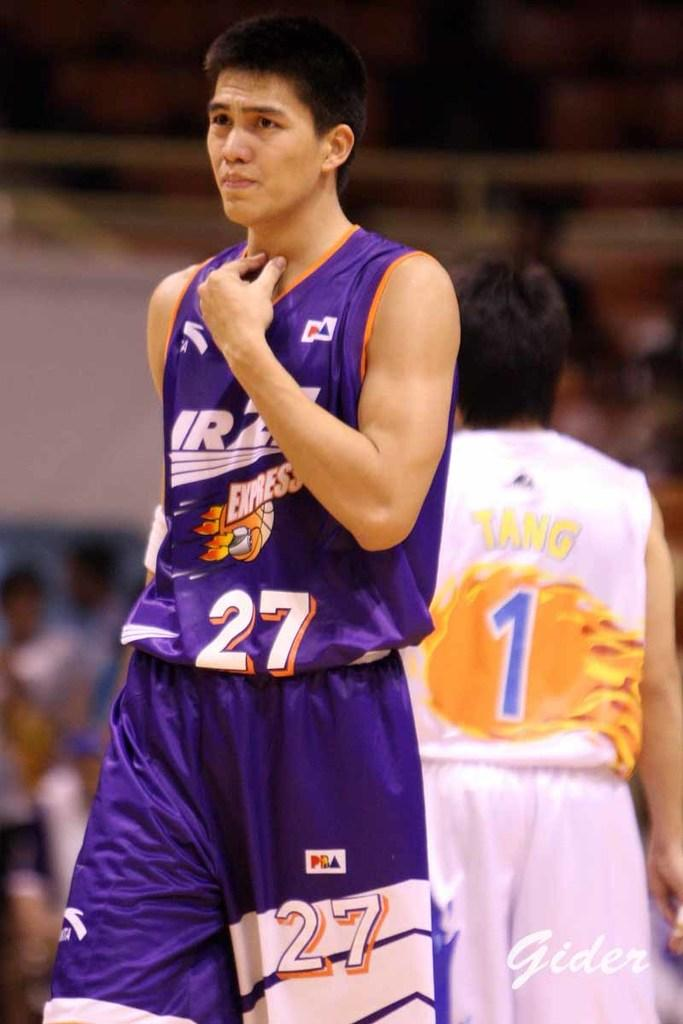What is the main action being performed by the person in the image? There is a person walking in the image. What color is the top worn by the person walking? The person is wearing a blue top. Can you describe the position of the other person in the image? There is a person standing on the right side of the image. How would you describe the background of the image? The background of the image is blurry. What type of swing can be seen in the image? There is no swing present in the image. How many eyes does the person walking have in the image? The image does not show the person's eyes, so it is impossible to determine the number of eyes they have. 